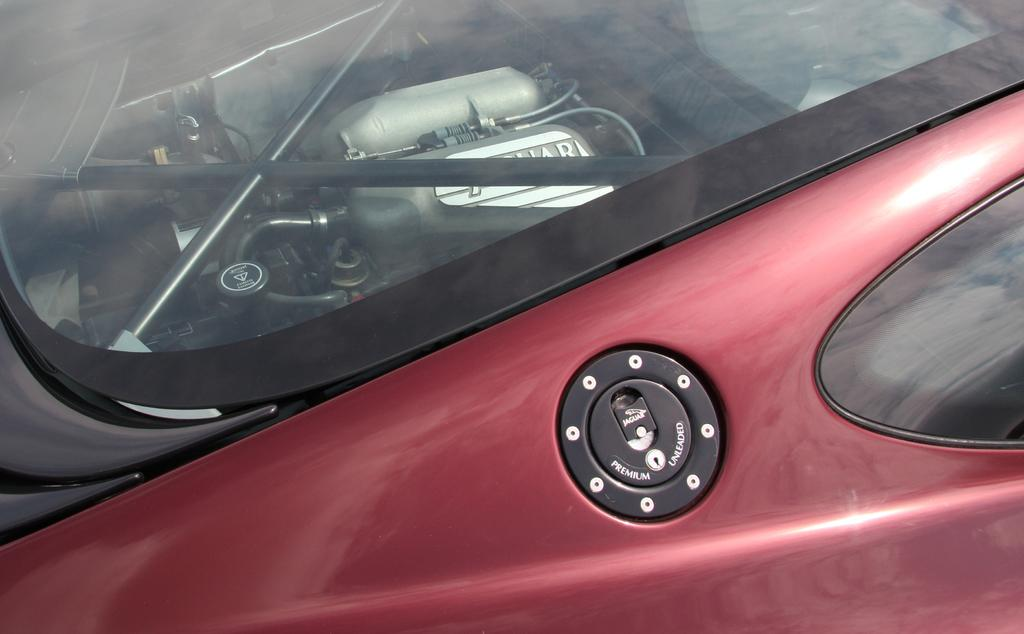What is the main subject of the image? The main subject of the image is a car. Can you describe what is visible through the glass of the car? There are cylinders visible through the glass of the car. How many minutes does it take for the paint to dry on the car in the image? There is no information about paint or drying time in the image, so we cannot answer this question. 